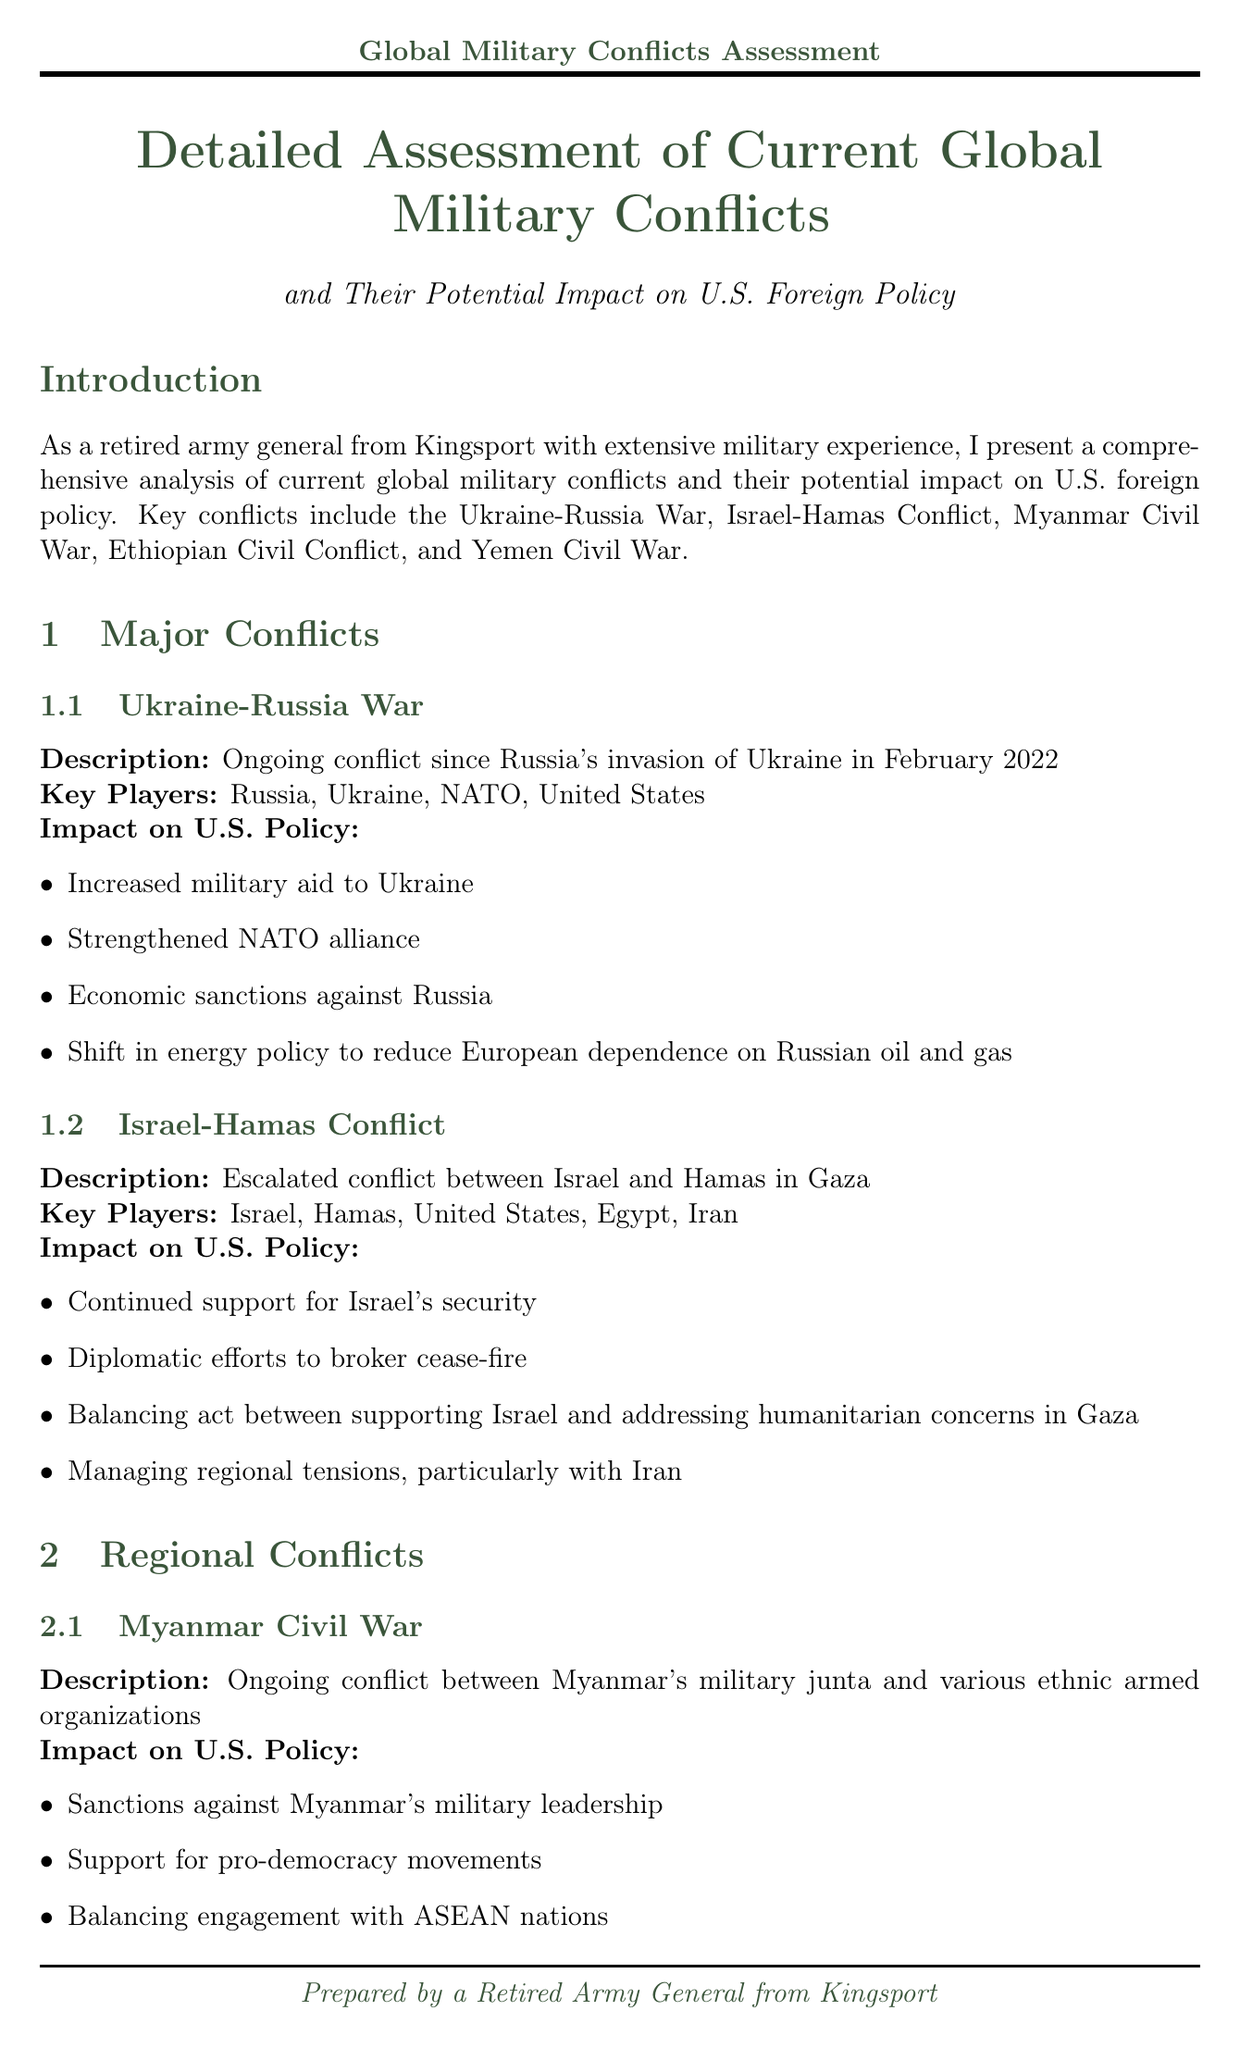What is the starting date of the Ukraine-Russia War? The Ukraine-Russia War began with Russia's invasion of Ukraine in February 2022.
Answer: February 2022 Which two countries are key players in the Israel-Hamas Conflict? Key players in the Israel-Hamas Conflict include Israel and Hamas.
Answer: Israel, Hamas What is one impact of the Ukraine-Russia War on U.S. policy? One impact is increased military aid to Ukraine.
Answer: Increased military aid to Ukraine What humanitarian efforts are associated with the Ethiopian Civil Conflict? Humanitarian aid efforts are highlighted in the context of the Ethiopian Civil Conflict.
Answer: Humanitarian aid efforts What is a concern related to nuclear proliferation mentioned in the document? The document mentions ongoing concerns about nuclear capabilities of North Korea and Iran.
Answer: Nuclear capabilities of North Korea and Iran What is a strategic consideration related to U.S. military focus? The document states a shift in military focus from counterterrorism to near-peer competition as a strategic consideration.
Answer: Shift in military focus from counterterrorism to near-peer competition Identify one area of military readiness focus according to the document. The document mentions cyber warfare capabilities as a focus area for military readiness.
Answer: Cyber warfare capabilities What is a recommended strategy for long-term regional stability? Developing comprehensive strategies for long-term regional stability is one of the recommendations.
Answer: Develop comprehensive strategies for long-term regional stability 